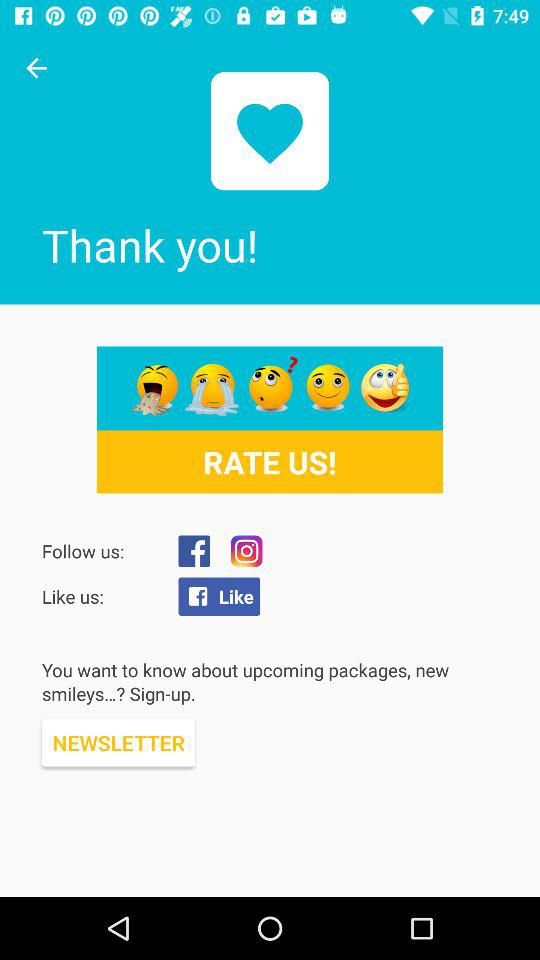How many smiley faces are there in total?
Answer the question using a single word or phrase. 5 